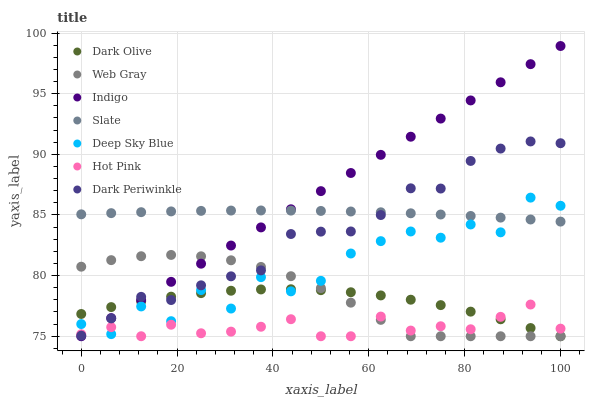Does Hot Pink have the minimum area under the curve?
Answer yes or no. Yes. Does Indigo have the maximum area under the curve?
Answer yes or no. Yes. Does Slate have the minimum area under the curve?
Answer yes or no. No. Does Slate have the maximum area under the curve?
Answer yes or no. No. Is Indigo the smoothest?
Answer yes or no. Yes. Is Deep Sky Blue the roughest?
Answer yes or no. Yes. Is Slate the smoothest?
Answer yes or no. No. Is Slate the roughest?
Answer yes or no. No. Does Web Gray have the lowest value?
Answer yes or no. Yes. Does Slate have the lowest value?
Answer yes or no. No. Does Indigo have the highest value?
Answer yes or no. Yes. Does Slate have the highest value?
Answer yes or no. No. Is Dark Olive less than Slate?
Answer yes or no. Yes. Is Slate greater than Hot Pink?
Answer yes or no. Yes. Does Dark Olive intersect Hot Pink?
Answer yes or no. Yes. Is Dark Olive less than Hot Pink?
Answer yes or no. No. Is Dark Olive greater than Hot Pink?
Answer yes or no. No. Does Dark Olive intersect Slate?
Answer yes or no. No. 